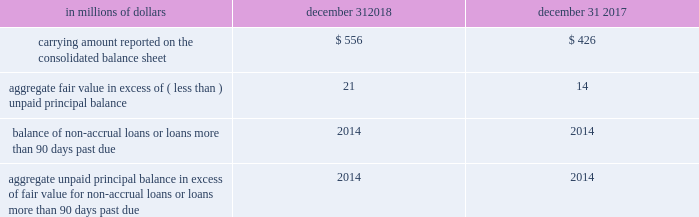Changes in the fair value of funded and unfunded credit products are classified in principal transactions in citi 2019s consolidated statement of income .
Related interest revenue is measured based on the contractual interest rates and reported as interest revenue on trading account assets or loan interest depending on the balance sheet classifications of the credit products .
The changes in fair value for the years ended december 31 , 2018 and 2017 due to instrument-specific credit risk totaled to a loss of $ 27 million and a gain of $ 10 million , respectively .
Certain investments in unallocated precious metals citigroup invests in unallocated precious metals accounts ( gold , silver , platinum and palladium ) as part of its commodity and foreign currency trading activities or to economically hedge certain exposures from issuing structured liabilities .
Under asc 815 , the investment is bifurcated into a debt host contract and a commodity forward derivative instrument .
Citigroup elects the fair value option for the debt host contract , and reports the debt host contract within trading account assets on the company 2019s consolidated balance sheet .
The total carrying amount of debt host contracts across unallocated precious metals accounts was approximately $ 0.4 billion and $ 0.9 billion at december 31 , 2018 and 2017 , respectively .
The amounts are expected to fluctuate based on trading activity in future periods .
As part of its commodity and foreign currency trading activities , citi trades unallocated precious metals investments and executes forward purchase and forward sale derivative contracts with trading counterparties .
When citi sells an unallocated precious metals investment , citi 2019s receivable from its depository bank is repaid and citi derecognizes its investment in the unallocated precious metal .
The forward purchase or sale contract with the trading counterparty indexed to unallocated precious metals is accounted for as a derivative , at fair value through earnings .
As of december 31 , 2018 , there were approximately $ 13.7 billion and $ 10.3 billion in notional amounts of such forward purchase and forward sale derivative contracts outstanding , respectively .
Certain investments in private equity and real estate ventures and certain equity method and other investments citigroup invests in private equity and real estate ventures for the purpose of earning investment returns and for capital appreciation .
The company has elected the fair value option for certain of these ventures , because such investments are considered similar to many private equity or hedge fund activities in citi 2019s investment companies , which are reported at fair value .
The fair value option brings consistency in the accounting and evaluation of these investments .
All investments ( debt and equity ) in such private equity and real estate entities are accounted for at fair value .
These investments are classified as investments on citigroup 2019s consolidated balance sheet .
Changes in the fair values of these investments are classified in other revenue in the company 2019s consolidated statement of income .
Citigroup also elected the fair value option for certain non-marketable equity securities whose risk is managed with derivative instruments that are accounted for at fair value through earnings .
These securities are classified as trading account assets on citigroup 2019s consolidated balance sheet .
Changes in the fair value of these securities and the related derivative instruments are recorded in principal transactions .
Effective january 1 , 2018 under asu 2016-01 and asu 2018-03 , a fair value option election is no longer required to measure these non-marketable equity securities through earnings .
See note 1 to the consolidated financial statements for additional details .
Certain mortgage loans held-for-sale citigroup has elected the fair value option for certain purchased and originated prime fixed-rate and conforming adjustable-rate first mortgage loans hfs .
These loans are intended for sale or securitization and are hedged with derivative instruments .
The company has elected the fair value option to mitigate accounting mismatches in cases where hedge accounting is complex and to achieve operational simplifications .
The table provides information about certain mortgage loans hfs carried at fair value: .
The changes in the fair values of these mortgage loans are reported in other revenue in the company 2019s consolidated statement of income .
There was no net change in fair value during the years ended december 31 , 2018 and 2017 due to instrument-specific credit risk .
Related interest income continues to be measured based on the contractual interest rates and reported as interest revenue in the consolidated statement of income. .
What was the percent of the carrying amount reported on the consolidated balance sheet of certain mortgage loans hfs from 2017 to 2018? 
Rationale: the carrying amount reported on the consolidated balance sheet of certain mortgage loans hfs increased by 30.5 % from 2017 to 2018
Computations: ((556 - 426) / 426)
Answer: 0.30516. 